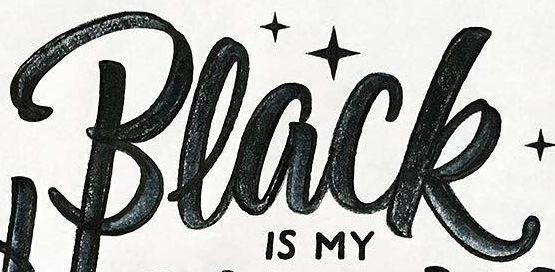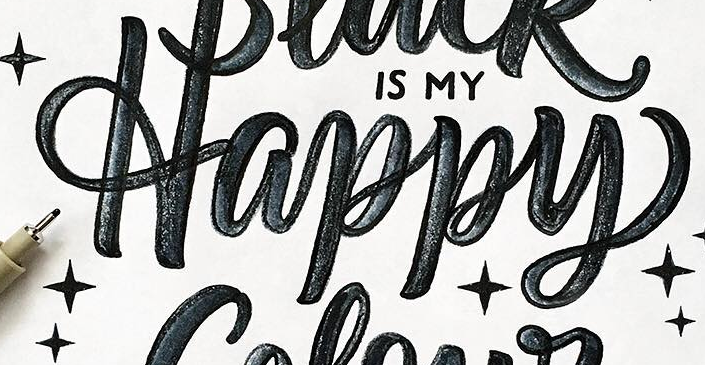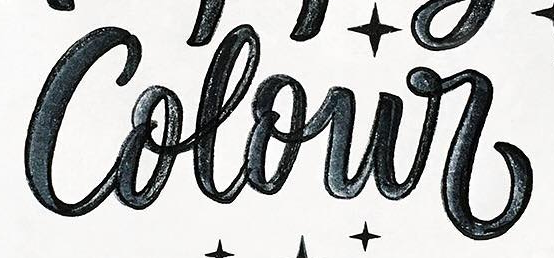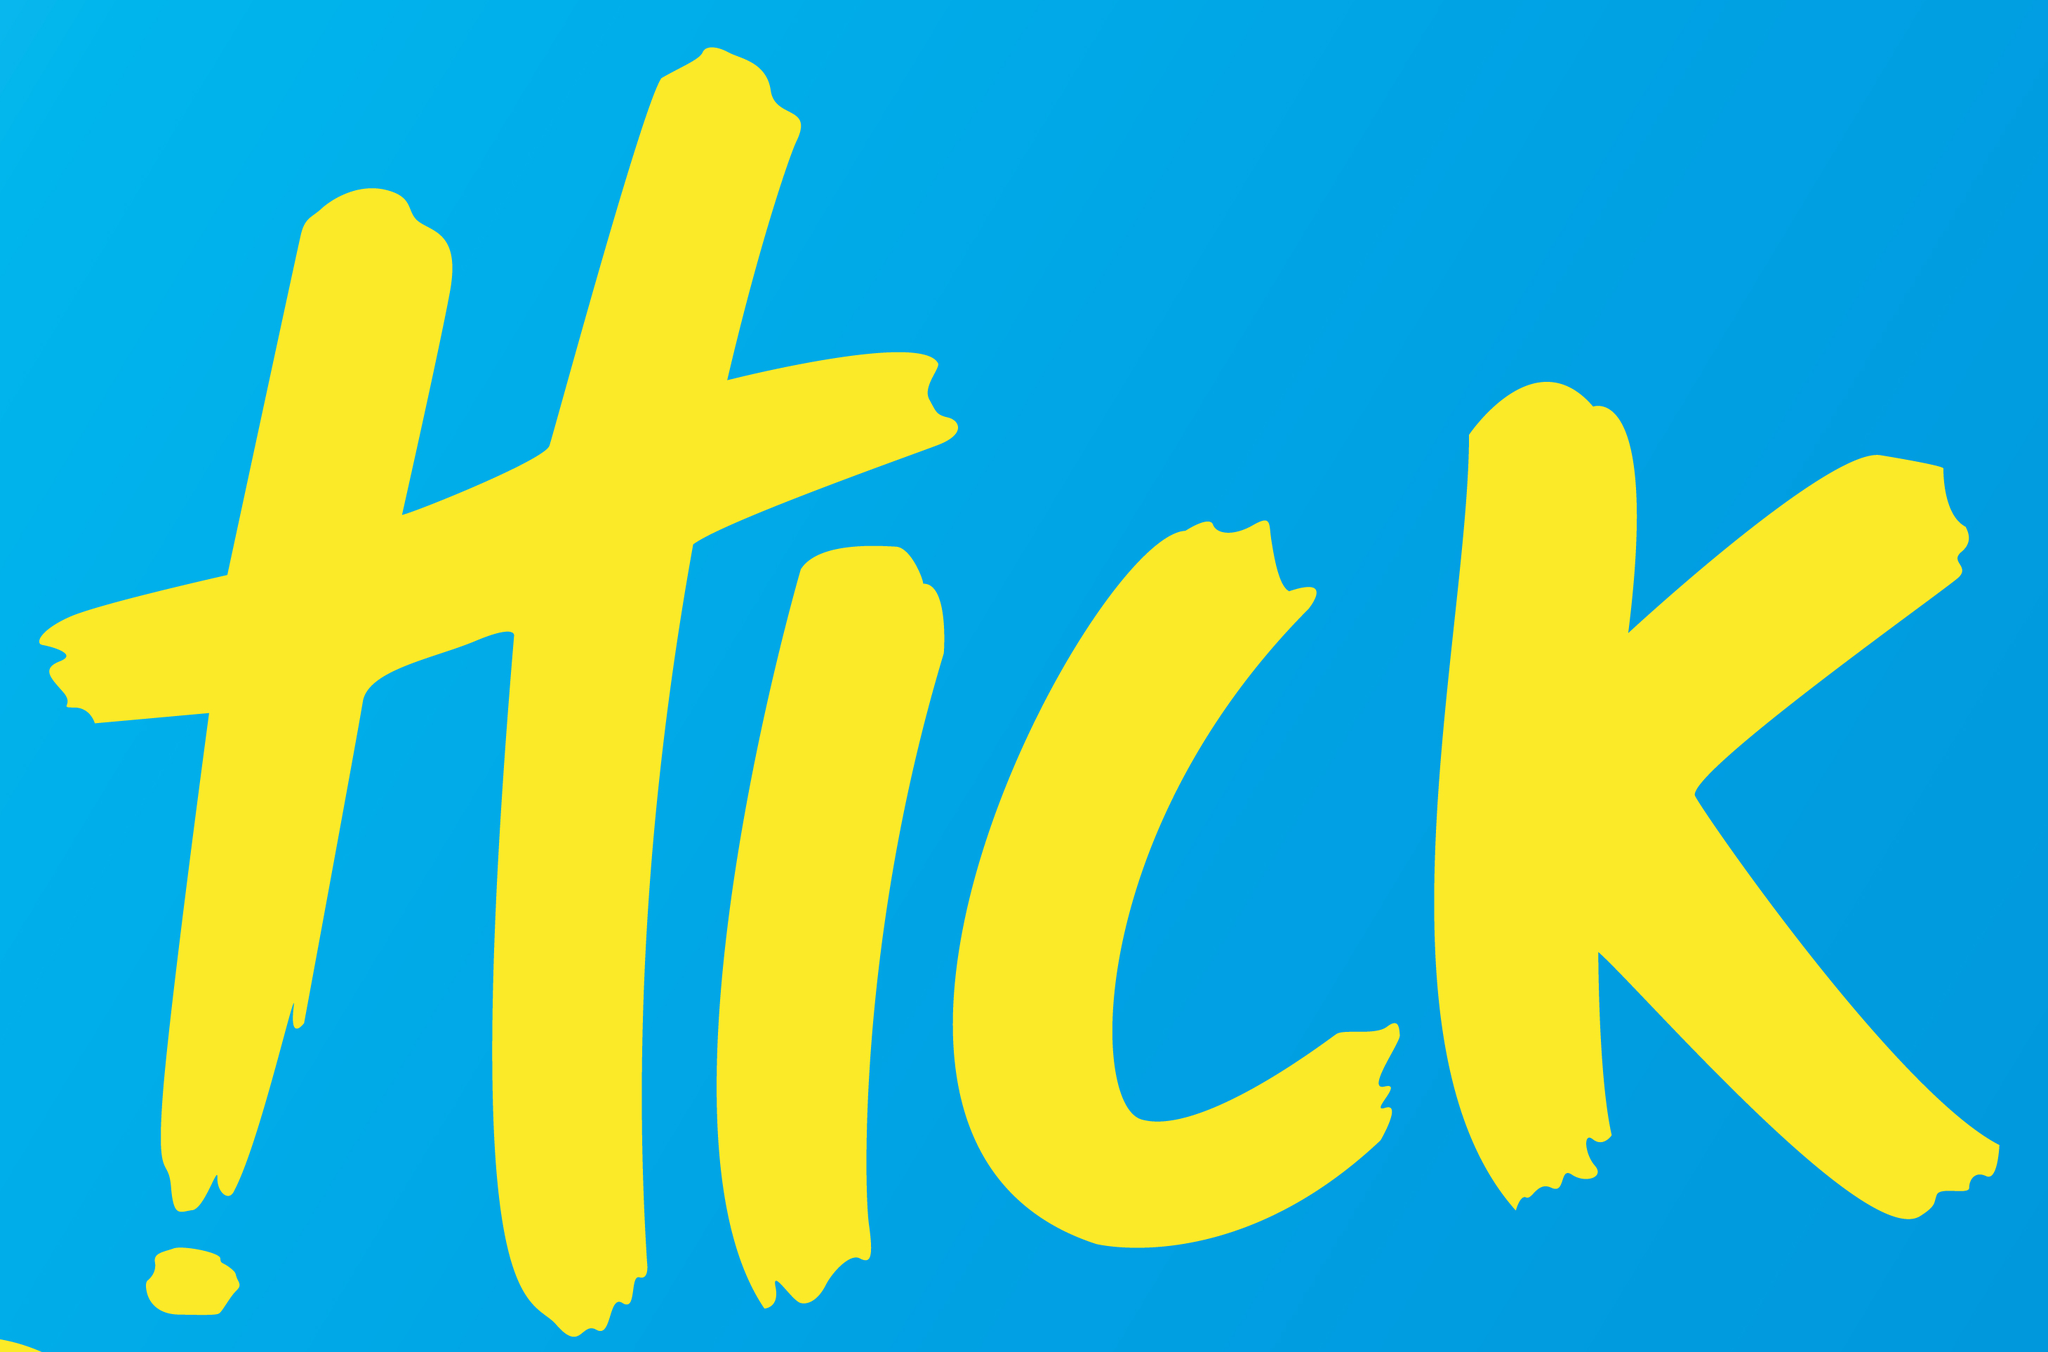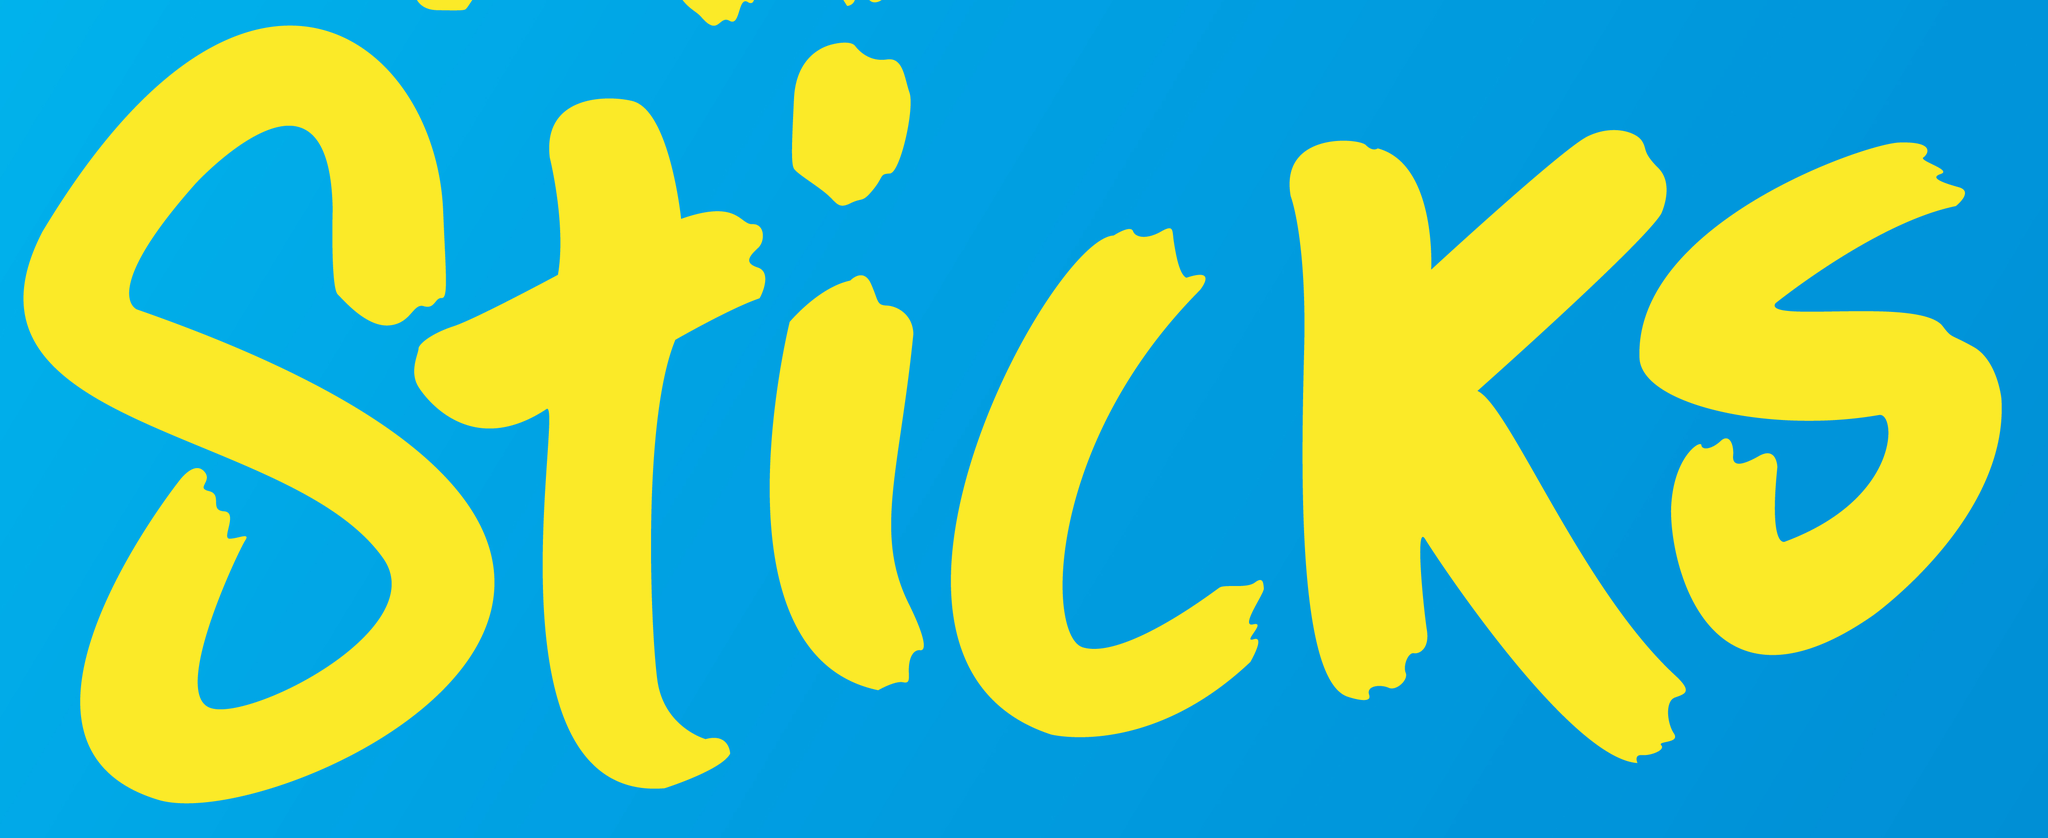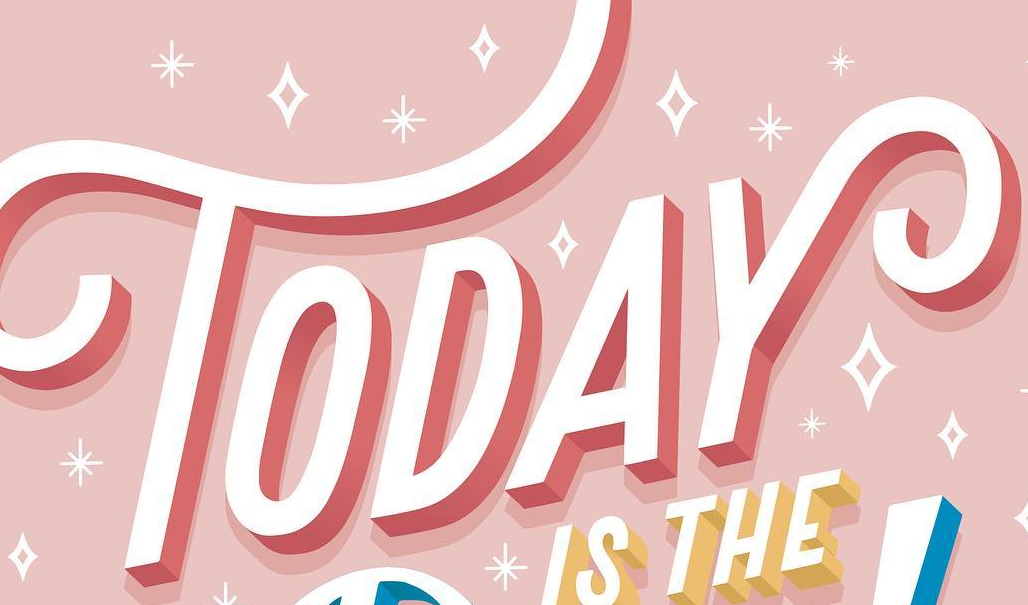Read the text from these images in sequence, separated by a semicolon. Black; Happy; Colour; HICK; Sticks; TODAY 